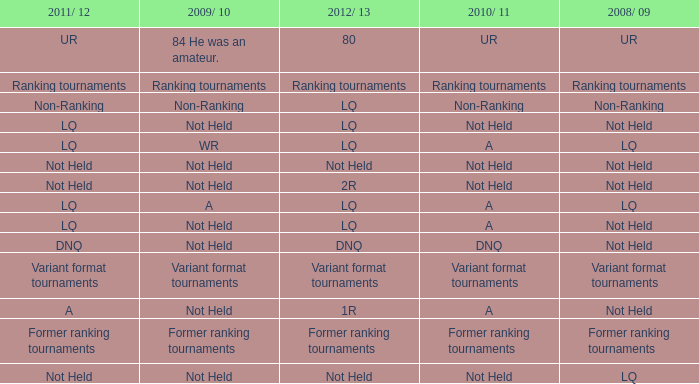When 2011/ 12 is non-ranking, what is the 2009/ 10? Non-Ranking. 